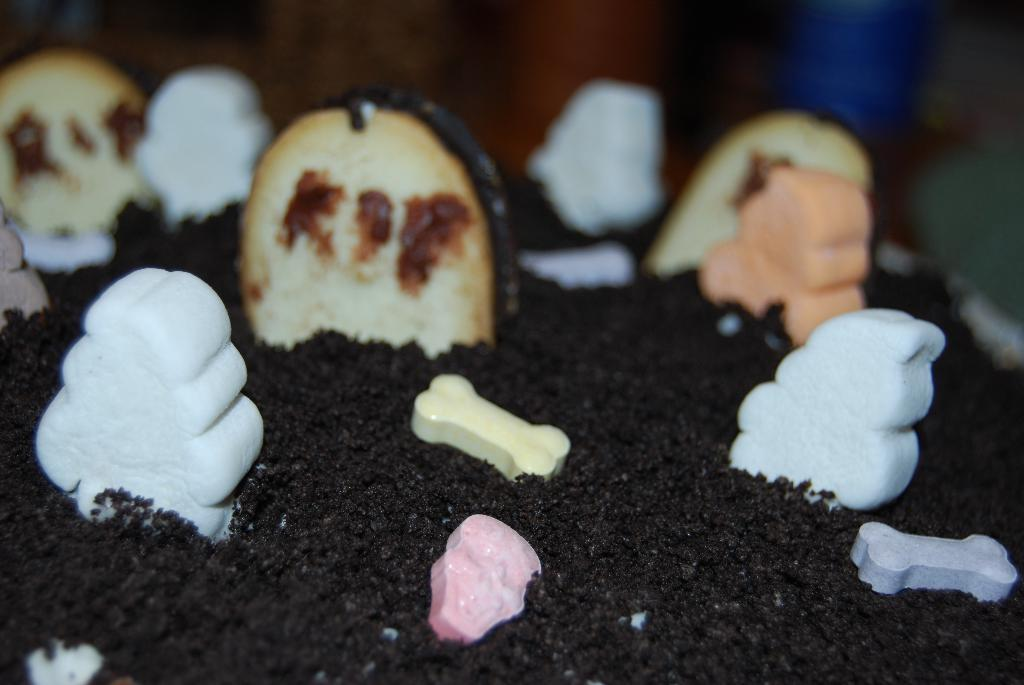What is the main subject of the image? There is a cake in the image. Can you describe the background of the image? The background of the image is blurred. What type of cabbage is being used to decorate the cake in the image? There is no cabbage present in the image, and therefore no such decoration can be observed. Is the cake being rained on in the image? There is no indication of rain in the image; it only shows a cake with a blurred background. 